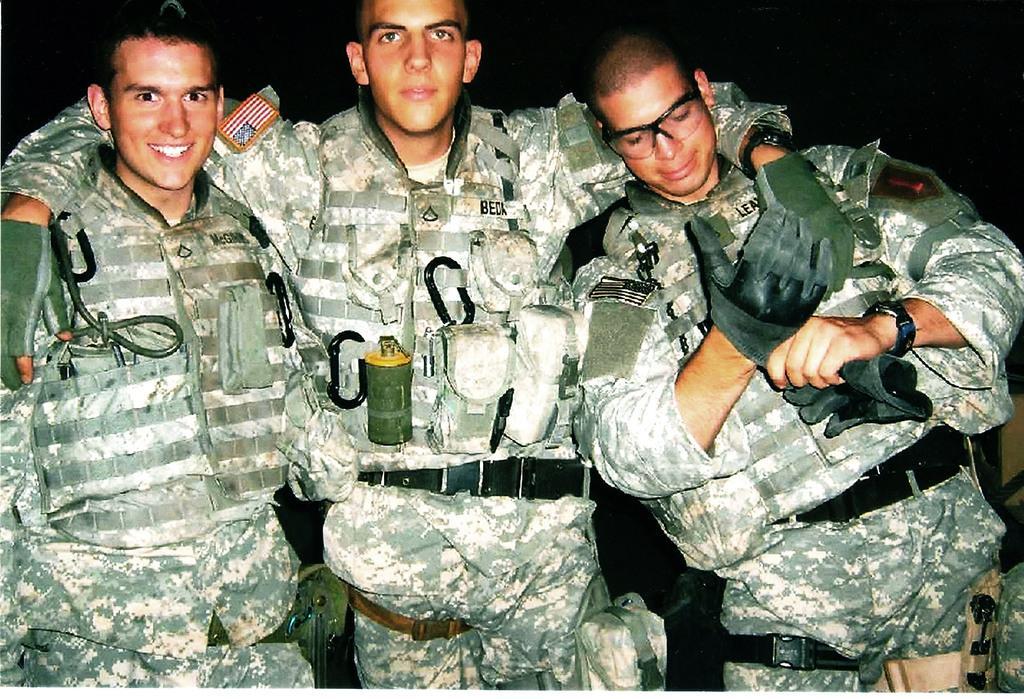Can you describe this image briefly? In this picture we can see three persons. There is a dark background. 